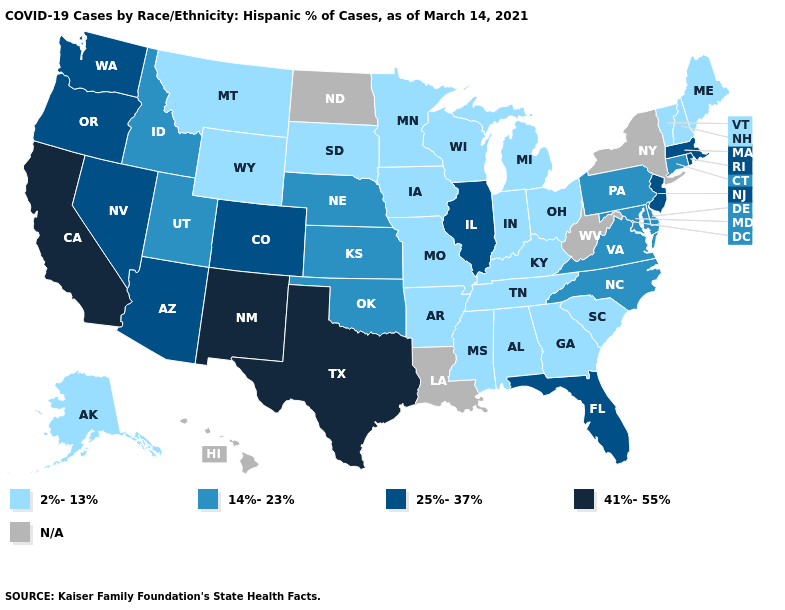What is the value of Louisiana?
Give a very brief answer. N/A. Among the states that border Oklahoma , does New Mexico have the highest value?
Answer briefly. Yes. Which states have the lowest value in the USA?
Concise answer only. Alabama, Alaska, Arkansas, Georgia, Indiana, Iowa, Kentucky, Maine, Michigan, Minnesota, Mississippi, Missouri, Montana, New Hampshire, Ohio, South Carolina, South Dakota, Tennessee, Vermont, Wisconsin, Wyoming. What is the highest value in the USA?
Quick response, please. 41%-55%. Name the states that have a value in the range 2%-13%?
Keep it brief. Alabama, Alaska, Arkansas, Georgia, Indiana, Iowa, Kentucky, Maine, Michigan, Minnesota, Mississippi, Missouri, Montana, New Hampshire, Ohio, South Carolina, South Dakota, Tennessee, Vermont, Wisconsin, Wyoming. Among the states that border New Hampshire , does Maine have the lowest value?
Answer briefly. Yes. What is the value of Illinois?
Short answer required. 25%-37%. What is the highest value in states that border Indiana?
Answer briefly. 25%-37%. Name the states that have a value in the range 25%-37%?
Be succinct. Arizona, Colorado, Florida, Illinois, Massachusetts, Nevada, New Jersey, Oregon, Rhode Island, Washington. What is the value of Michigan?
Quick response, please. 2%-13%. Name the states that have a value in the range N/A?
Answer briefly. Hawaii, Louisiana, New York, North Dakota, West Virginia. What is the value of Rhode Island?
Be succinct. 25%-37%. Name the states that have a value in the range 41%-55%?
Answer briefly. California, New Mexico, Texas. Among the states that border Texas , which have the lowest value?
Write a very short answer. Arkansas. 